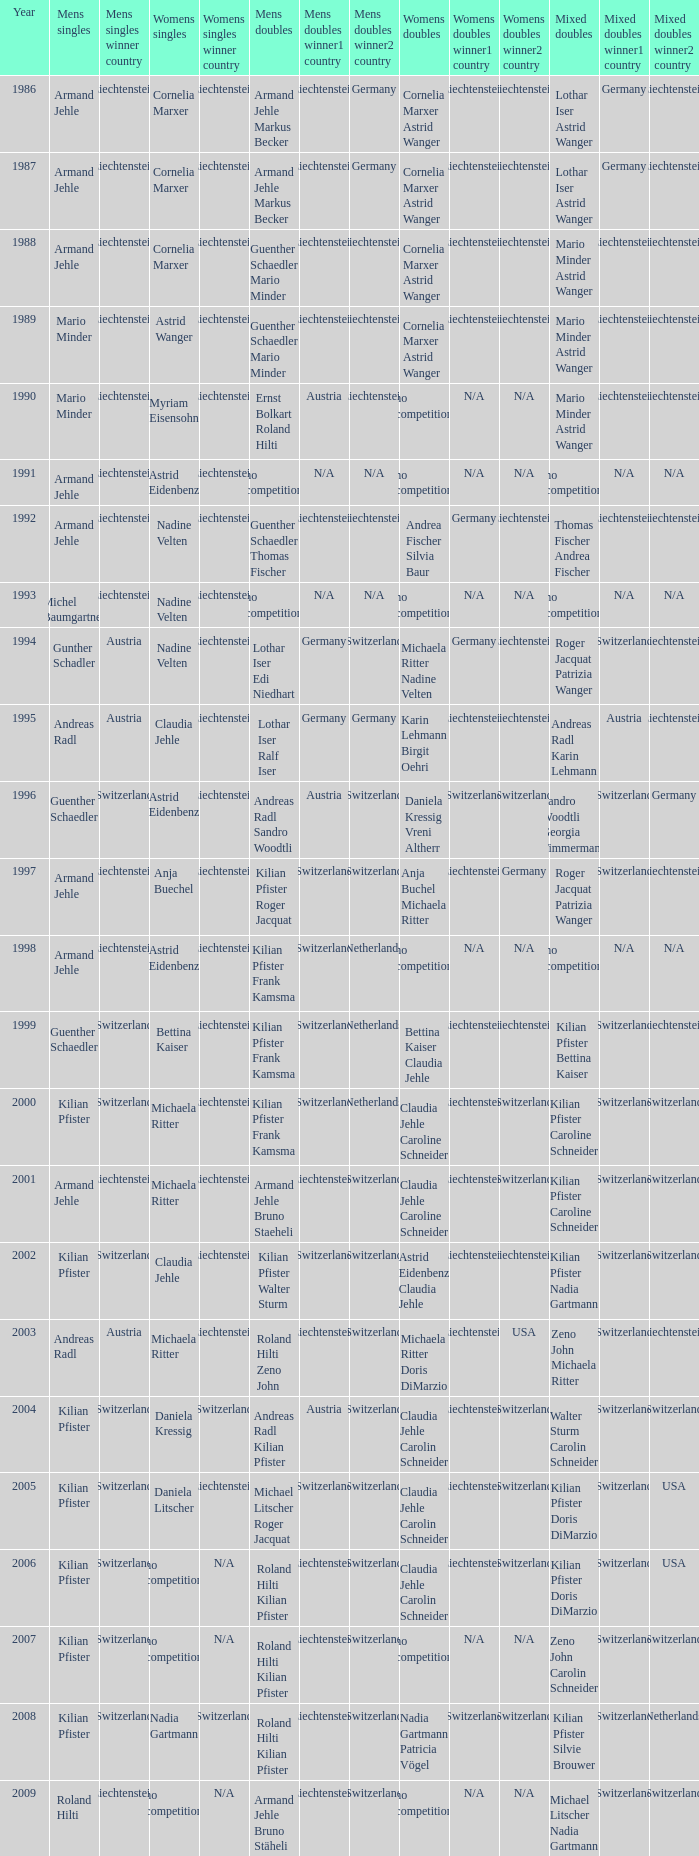What is the most current year where the women's doubles champions are astrid eidenbenz claudia jehle 2002.0. 